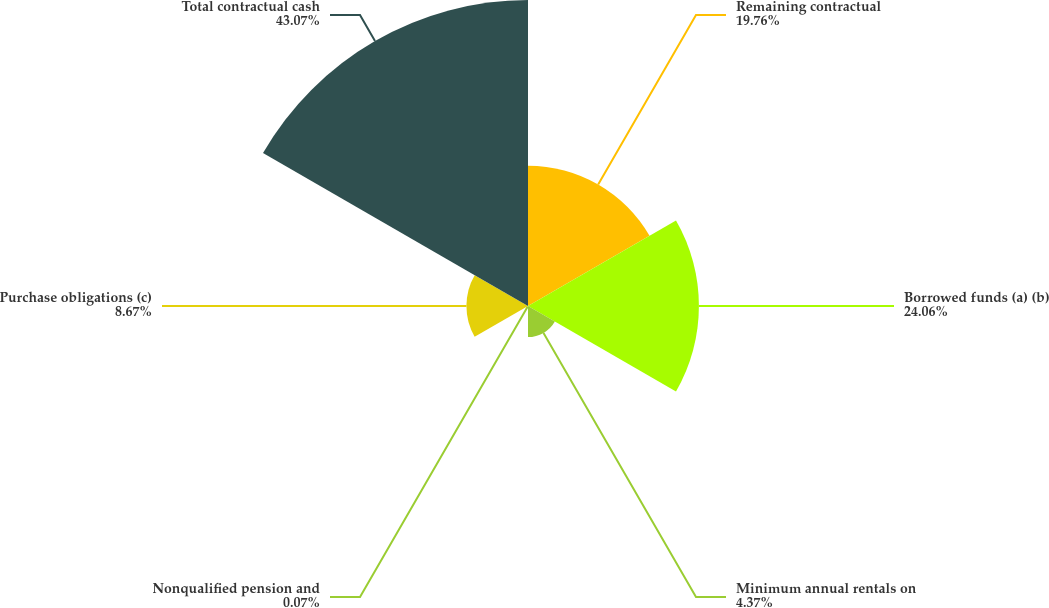Convert chart. <chart><loc_0><loc_0><loc_500><loc_500><pie_chart><fcel>Remaining contractual<fcel>Borrowed funds (a) (b)<fcel>Minimum annual rentals on<fcel>Nonqualified pension and<fcel>Purchase obligations (c)<fcel>Total contractual cash<nl><fcel>19.76%<fcel>24.06%<fcel>4.37%<fcel>0.07%<fcel>8.67%<fcel>43.08%<nl></chart> 